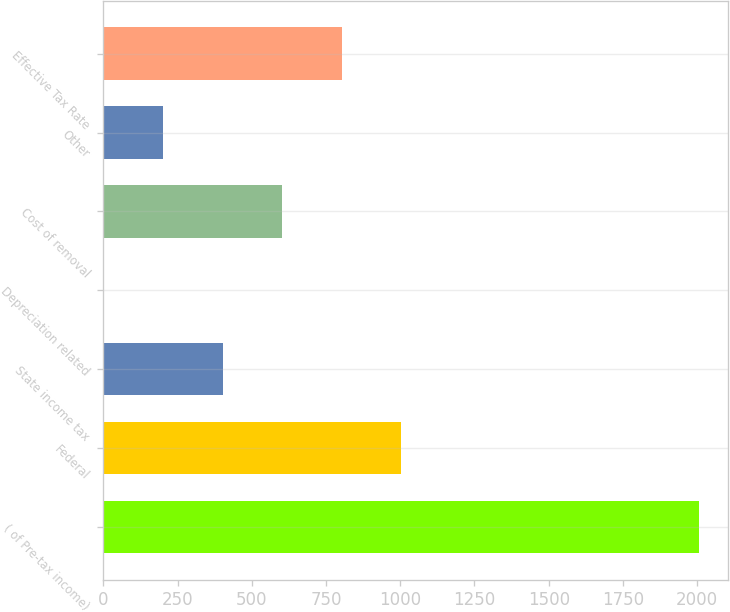<chart> <loc_0><loc_0><loc_500><loc_500><bar_chart><fcel>( of Pre-tax income)<fcel>Federal<fcel>State income tax<fcel>Depreciation related<fcel>Cost of removal<fcel>Other<fcel>Effective Tax Rate<nl><fcel>2005<fcel>1003.5<fcel>402.6<fcel>2<fcel>602.9<fcel>202.3<fcel>803.2<nl></chart> 